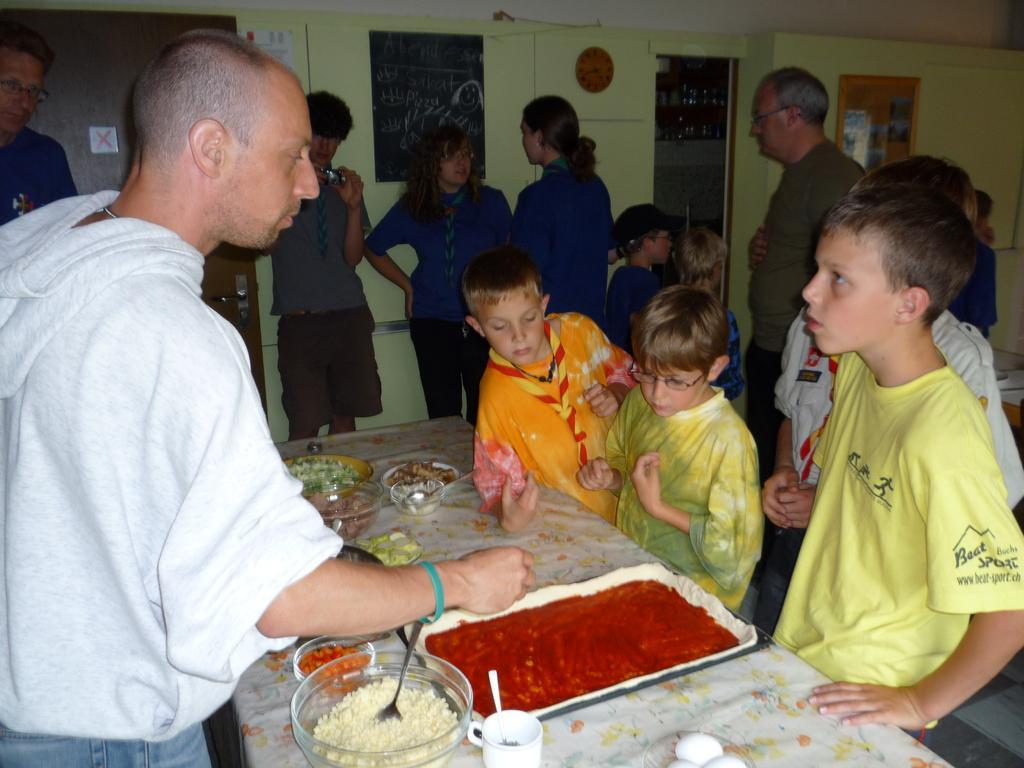Could you give a brief overview of what you see in this image? Here we can see few persons are standing on the floor. This is a table. On the table there is a cloth, bowls, cup, spoons, and food. In the background we can see boards, door, and wall. 